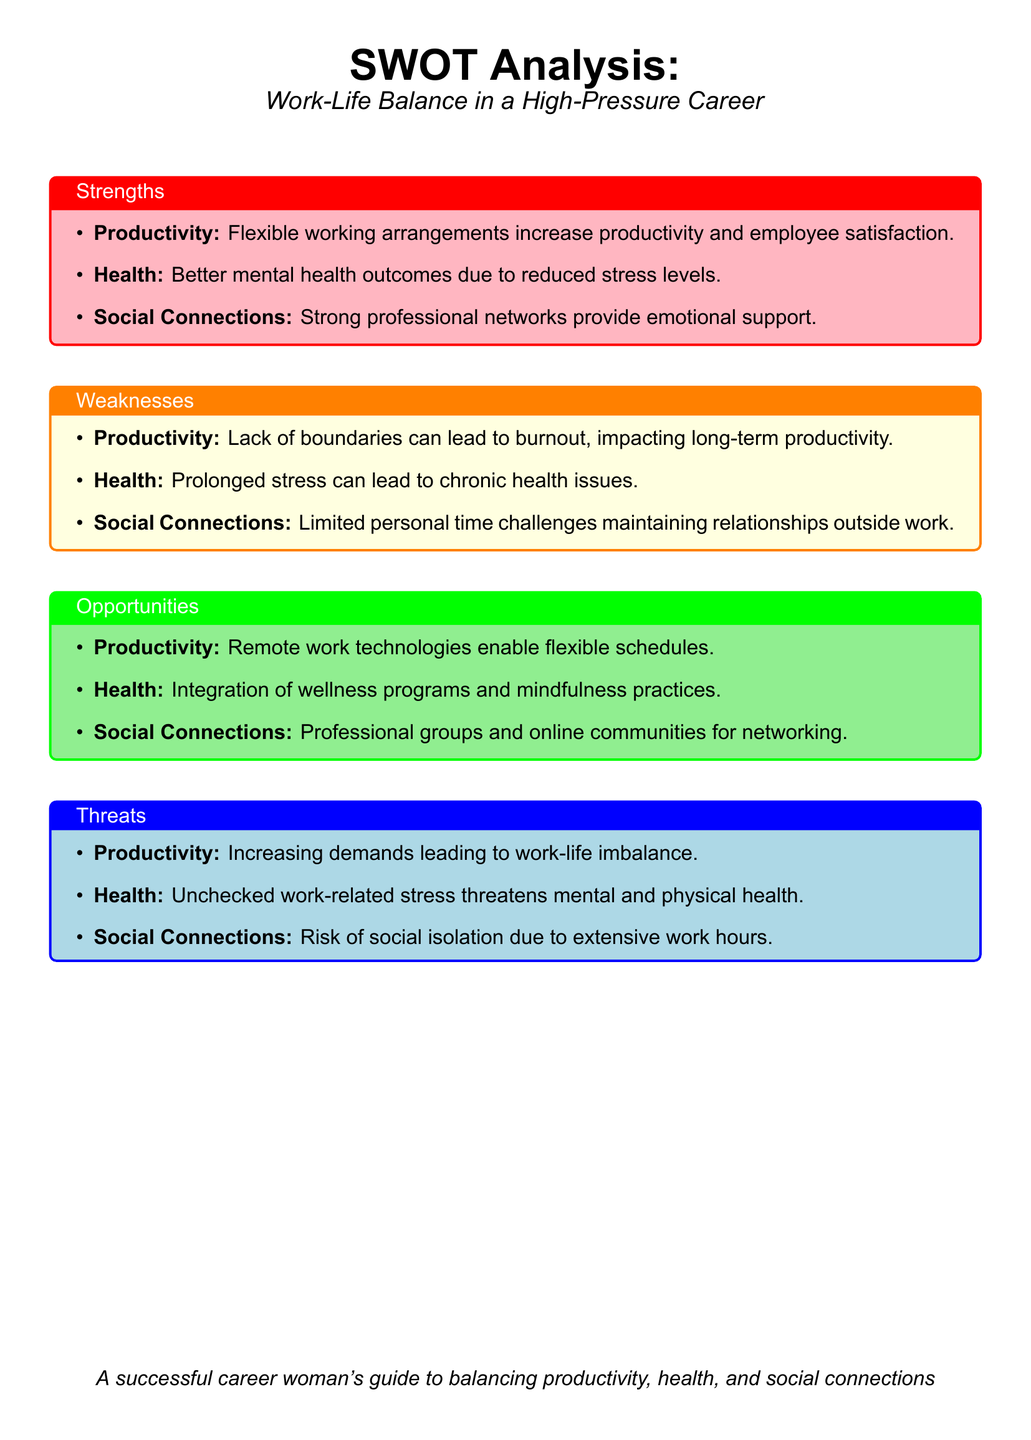What is the main focus of the SWOT analysis? The SWOT analysis focuses on the work-life balance in a high-pressure career, examining productivity, health, and social connections.
Answer: Work-Life Balance in a High-Pressure Career What color is used for the Strengths section? The Strengths section is presented in light pink.
Answer: Light pink What are two factors that improve health according to the Strengths section? The Strengths section mentions that better mental health outcomes and reduced stress levels improve health.
Answer: Better mental health outcomes, reduced stress levels What is a key threat related to productivity? The threat regarding productivity highlights increasing demands leading to work-life imbalance.
Answer: Increasing demands leading to work-life imbalance What opportunity suggests a method to enhance social connections? The opportunity regarding social connections points to professional groups and online communities for networking.
Answer: Professional groups and online communities What is listed as a weakness that could impact long-term productivity? A lack of boundaries, which can lead to burnout, is listed as a weakness impacting long-term productivity.
Answer: Lack of boundaries leading to burnout 